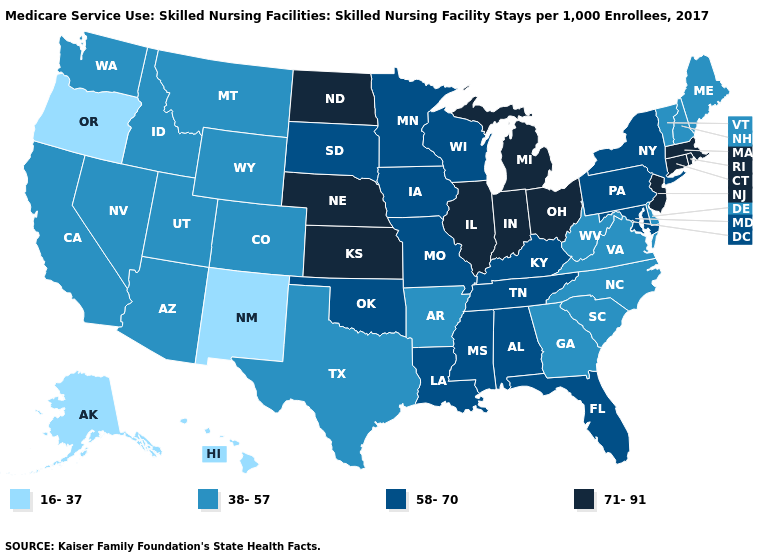Which states have the lowest value in the USA?
Write a very short answer. Alaska, Hawaii, New Mexico, Oregon. What is the value of Delaware?
Answer briefly. 38-57. Is the legend a continuous bar?
Quick response, please. No. What is the value of New York?
Quick response, please. 58-70. Name the states that have a value in the range 71-91?
Answer briefly. Connecticut, Illinois, Indiana, Kansas, Massachusetts, Michigan, Nebraska, New Jersey, North Dakota, Ohio, Rhode Island. What is the lowest value in the South?
Quick response, please. 38-57. Does Washington have the same value as New Mexico?
Answer briefly. No. How many symbols are there in the legend?
Concise answer only. 4. Which states have the lowest value in the USA?
Concise answer only. Alaska, Hawaii, New Mexico, Oregon. What is the value of Maryland?
Short answer required. 58-70. Among the states that border Minnesota , does North Dakota have the highest value?
Keep it brief. Yes. Does Louisiana have a higher value than Oregon?
Answer briefly. Yes. Which states hav the highest value in the Northeast?
Write a very short answer. Connecticut, Massachusetts, New Jersey, Rhode Island. Among the states that border Minnesota , does South Dakota have the highest value?
Short answer required. No. Which states have the lowest value in the South?
Short answer required. Arkansas, Delaware, Georgia, North Carolina, South Carolina, Texas, Virginia, West Virginia. 